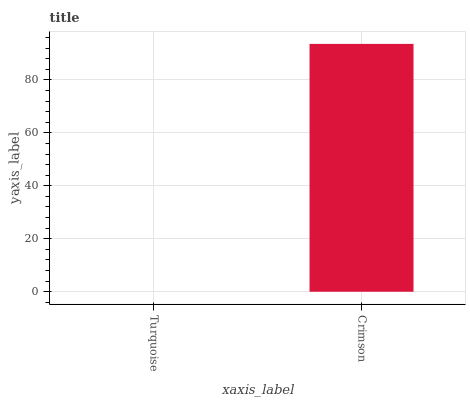Is Turquoise the minimum?
Answer yes or no. Yes. Is Crimson the maximum?
Answer yes or no. Yes. Is Crimson the minimum?
Answer yes or no. No. Is Crimson greater than Turquoise?
Answer yes or no. Yes. Is Turquoise less than Crimson?
Answer yes or no. Yes. Is Turquoise greater than Crimson?
Answer yes or no. No. Is Crimson less than Turquoise?
Answer yes or no. No. Is Crimson the high median?
Answer yes or no. Yes. Is Turquoise the low median?
Answer yes or no. Yes. Is Turquoise the high median?
Answer yes or no. No. Is Crimson the low median?
Answer yes or no. No. 